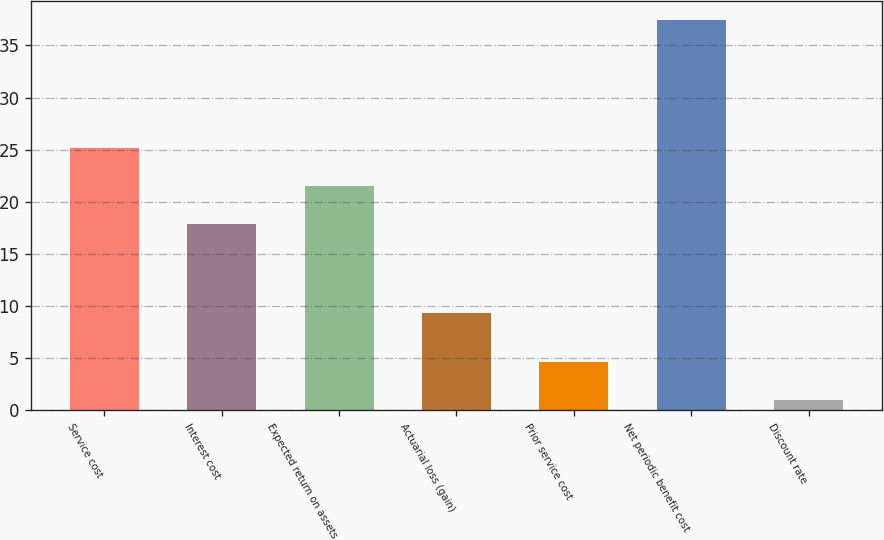Convert chart to OTSL. <chart><loc_0><loc_0><loc_500><loc_500><bar_chart><fcel>Service cost<fcel>Interest cost<fcel>Expected return on assets<fcel>Actuarial loss (gain)<fcel>Prior service cost<fcel>Net periodic benefit cost<fcel>Discount rate<nl><fcel>25.18<fcel>17.9<fcel>21.54<fcel>9.3<fcel>4.64<fcel>37.4<fcel>1<nl></chart> 